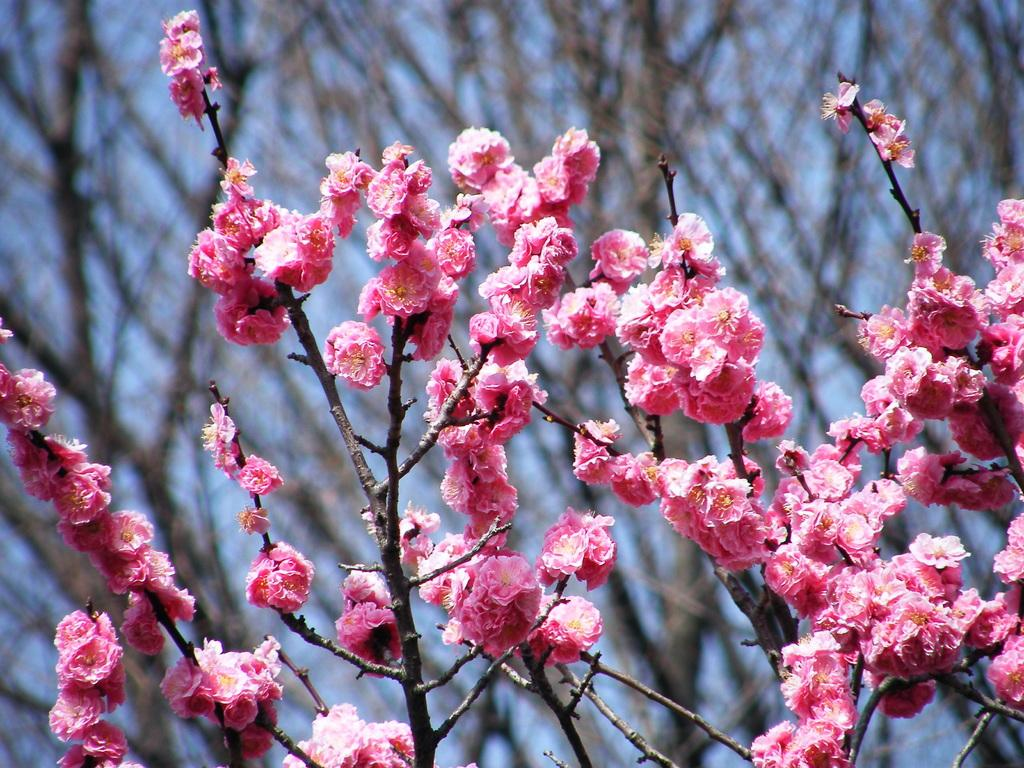What can be seen in the foreground of the picture? There are flowers and stems of a tree in the foreground of the picture. How is the background of the image depicted? The background of the image is blurred. What is visible in the background of the image? There is a tree and the sky visible in the background of the image. What type of industry can be seen in the middle of the image? There is no industry present in the image; it features flowers, tree stems, and a blurred background with a tree and the sky. 